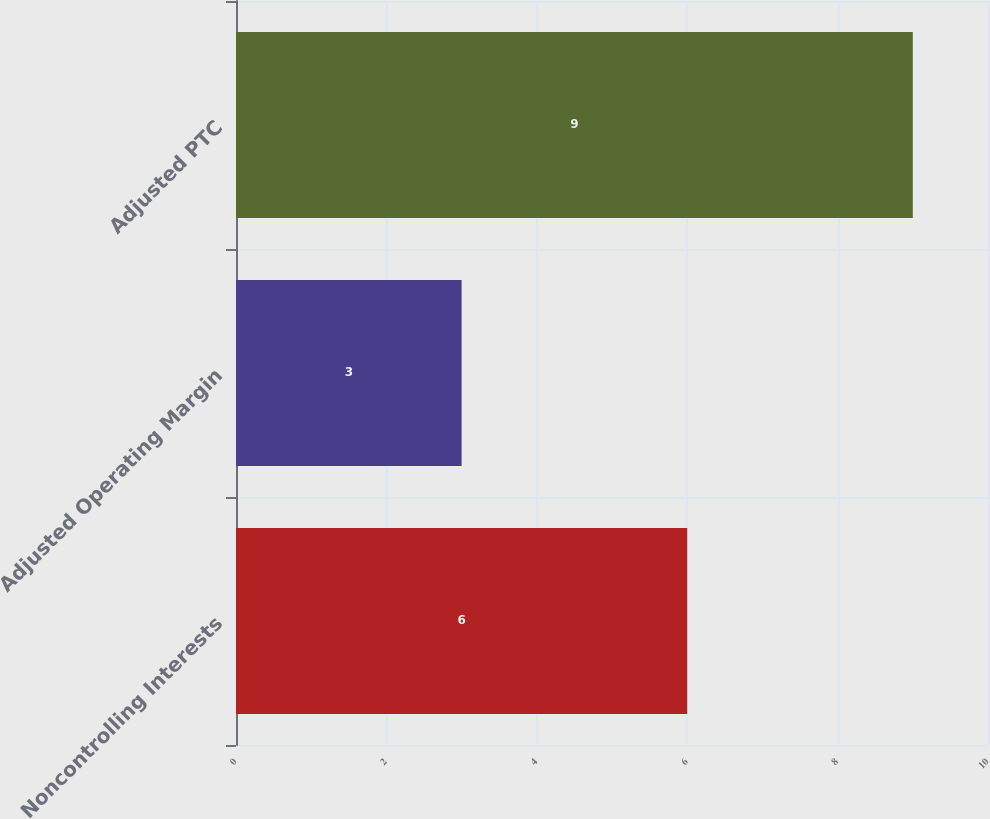Convert chart. <chart><loc_0><loc_0><loc_500><loc_500><bar_chart><fcel>Noncontrolling Interests<fcel>Adjusted Operating Margin<fcel>Adjusted PTC<nl><fcel>6<fcel>3<fcel>9<nl></chart> 